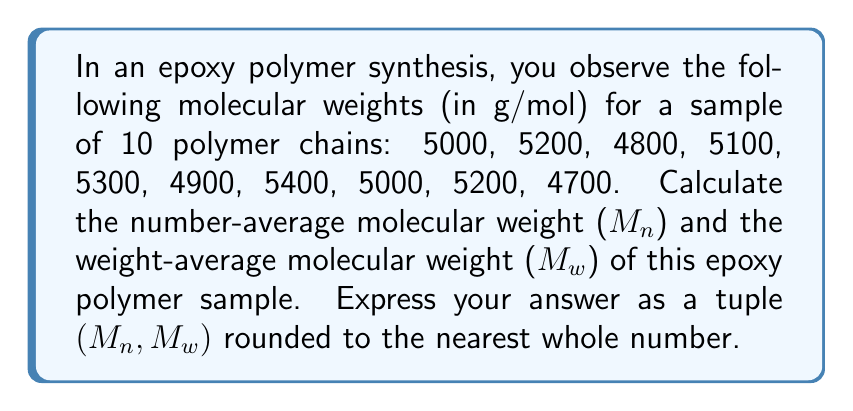Solve this math problem. To solve this problem, we need to calculate both $M_n$ and $M_w$ using the given molecular weights.

1. Number-average molecular weight ($M_n$):
   $M_n = \frac{\sum N_i M_i}{\sum N_i}$
   Where $N_i$ is the number of molecules with molecular weight $M_i$.

   In this case, we have 10 molecules in total, each with a different weight.
   $M_n = \frac{5000 + 5200 + 4800 + 5100 + 5300 + 4900 + 5400 + 5000 + 5200 + 4700}{10}$
   $M_n = \frac{50600}{10} = 5060$ g/mol

2. Weight-average molecular weight ($M_w$):
   $M_w = \frac{\sum N_i M_i^2}{\sum N_i M_i}$

   Numerator: $\sum N_i M_i^2 = 5000^2 + 5200^2 + 4800^2 + 5100^2 + 5300^2 + 4900^2 + 5400^2 + 5000^2 + 5200^2 + 4700^2$
   $= 256,130,000$

   Denominator: $\sum N_i M_i = 50600$ (from step 1)

   $M_w = \frac{256,130,000}{50600} = 5061.86$ g/mol

Rounding both values to the nearest whole number:
$M_n = 5060$ g/mol
$M_w = 5062$ g/mol
Answer: (5060, 5062) 